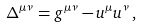<formula> <loc_0><loc_0><loc_500><loc_500>\Delta ^ { \mu \nu } = g ^ { \mu \nu } - u ^ { \mu } u ^ { \nu } \, ,</formula> 